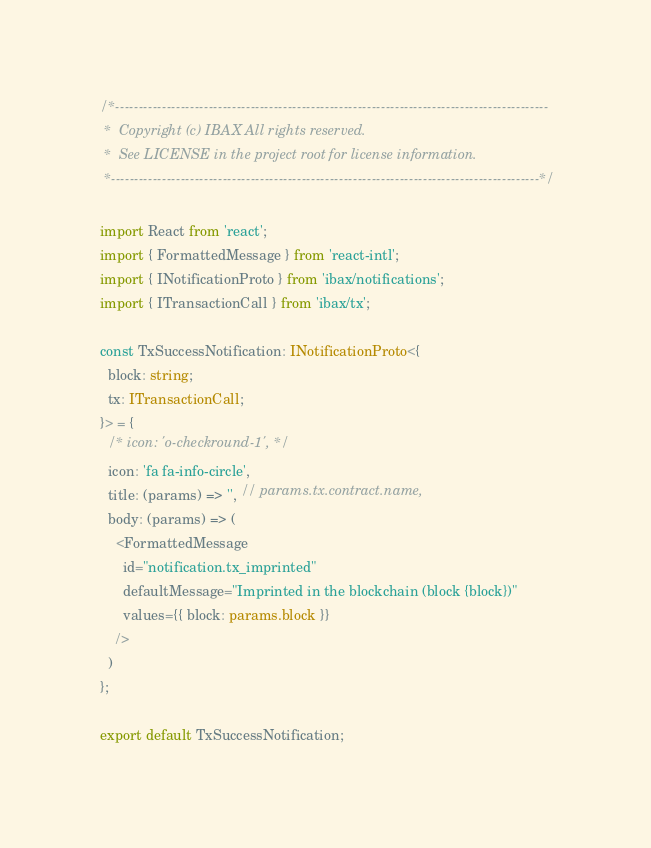<code> <loc_0><loc_0><loc_500><loc_500><_TypeScript_>/*---------------------------------------------------------------------------------------------
 *  Copyright (c) IBAX All rights reserved.
 *  See LICENSE in the project root for license information.
 *--------------------------------------------------------------------------------------------*/

import React from 'react';
import { FormattedMessage } from 'react-intl';
import { INotificationProto } from 'ibax/notifications';
import { ITransactionCall } from 'ibax/tx';

const TxSuccessNotification: INotificationProto<{
  block: string;
  tx: ITransactionCall;
}> = {
  /* icon: 'o-checkround-1', */
  icon: 'fa fa-info-circle',
  title: (params) => '', // params.tx.contract.name,
  body: (params) => (
    <FormattedMessage
      id="notification.tx_imprinted"
      defaultMessage="Imprinted in the blockchain (block {block})"
      values={{ block: params.block }}
    />
  )
};

export default TxSuccessNotification;
</code> 